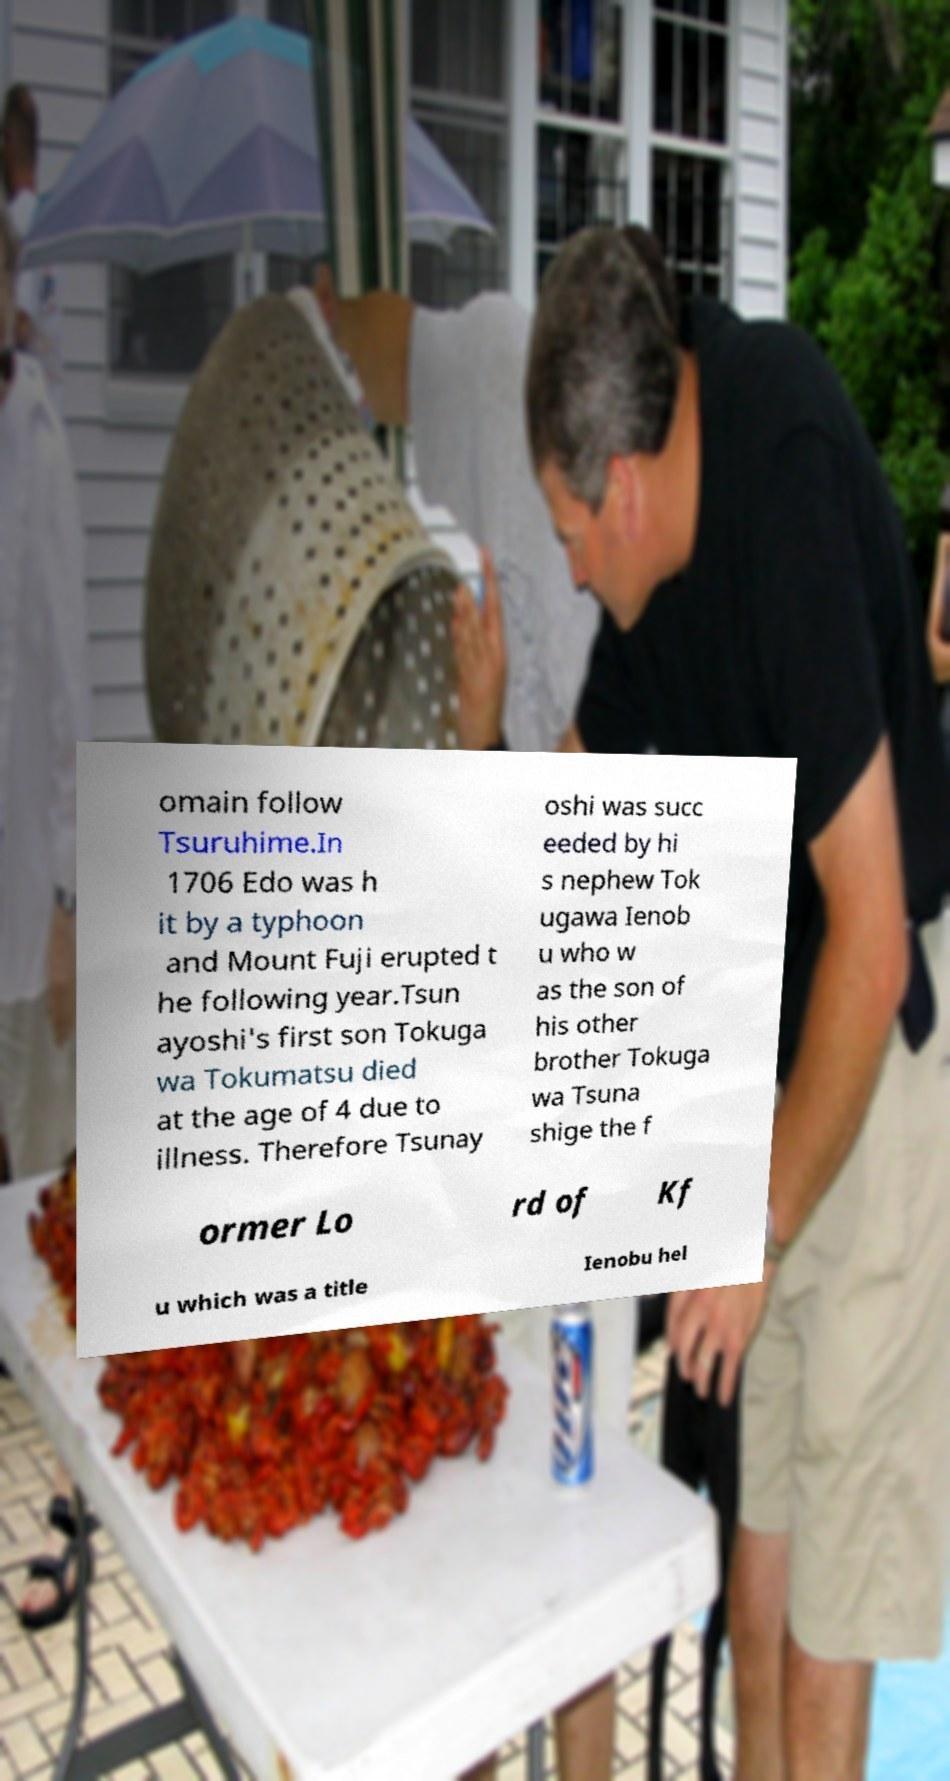Please identify and transcribe the text found in this image. omain follow Tsuruhime.In 1706 Edo was h it by a typhoon and Mount Fuji erupted t he following year.Tsun ayoshi's first son Tokuga wa Tokumatsu died at the age of 4 due to illness. Therefore Tsunay oshi was succ eeded by hi s nephew Tok ugawa Ienob u who w as the son of his other brother Tokuga wa Tsuna shige the f ormer Lo rd of Kf u which was a title Ienobu hel 